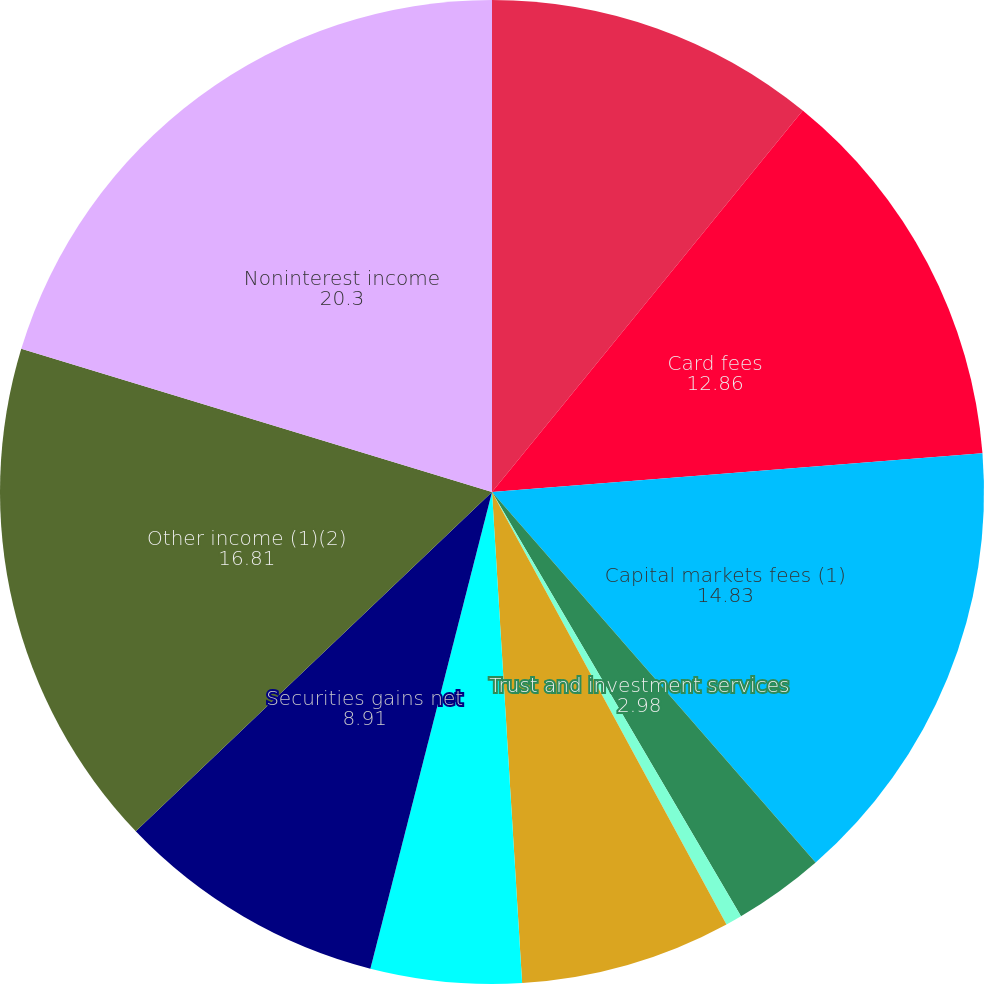<chart> <loc_0><loc_0><loc_500><loc_500><pie_chart><fcel>Service charges and fees (1)<fcel>Card fees<fcel>Capital markets fees (1)<fcel>Trust and investment services<fcel>Letter of credit and loan fees<fcel>Foreign exchange and interest<fcel>Mortgage banking fees<fcel>Securities gains net<fcel>Other income (1)(2)<fcel>Noninterest income<nl><fcel>10.88%<fcel>12.86%<fcel>14.83%<fcel>2.98%<fcel>0.54%<fcel>6.93%<fcel>4.95%<fcel>8.91%<fcel>16.81%<fcel>20.3%<nl></chart> 